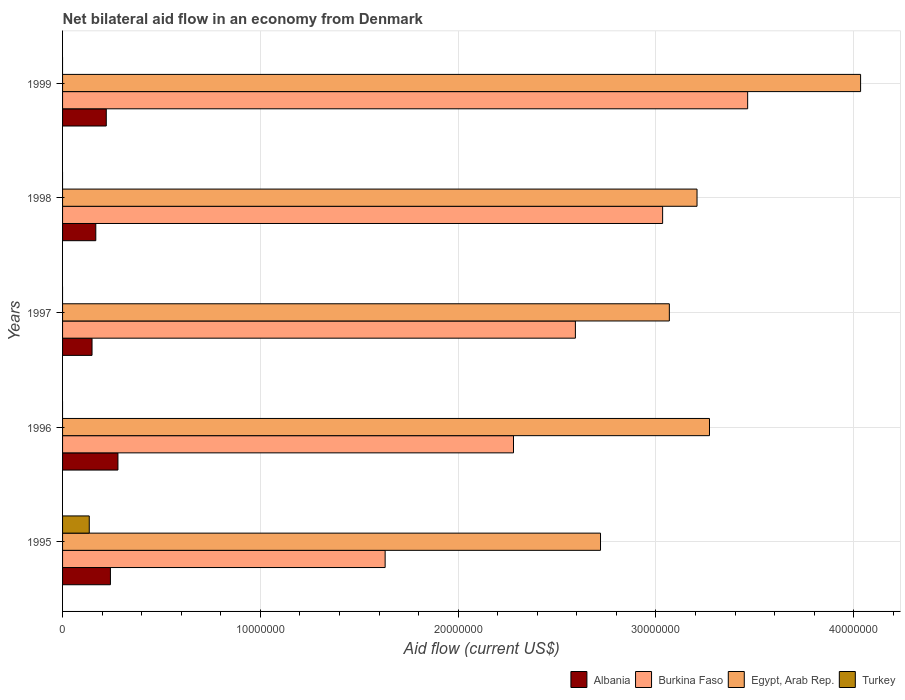How many groups of bars are there?
Provide a succinct answer. 5. How many bars are there on the 1st tick from the bottom?
Provide a succinct answer. 4. What is the label of the 2nd group of bars from the top?
Your answer should be compact. 1998. What is the net bilateral aid flow in Turkey in 1996?
Your answer should be very brief. 0. Across all years, what is the maximum net bilateral aid flow in Turkey?
Give a very brief answer. 1.35e+06. Across all years, what is the minimum net bilateral aid flow in Egypt, Arab Rep.?
Provide a short and direct response. 2.72e+07. What is the total net bilateral aid flow in Albania in the graph?
Ensure brevity in your answer.  1.06e+07. What is the difference between the net bilateral aid flow in Egypt, Arab Rep. in 1998 and that in 1999?
Your response must be concise. -8.27e+06. What is the difference between the net bilateral aid flow in Egypt, Arab Rep. in 1996 and the net bilateral aid flow in Burkina Faso in 1998?
Make the answer very short. 2.37e+06. What is the average net bilateral aid flow in Albania per year?
Keep it short and to the point. 2.12e+06. In the year 1995, what is the difference between the net bilateral aid flow in Burkina Faso and net bilateral aid flow in Albania?
Offer a very short reply. 1.39e+07. What is the ratio of the net bilateral aid flow in Egypt, Arab Rep. in 1996 to that in 1997?
Give a very brief answer. 1.07. Is the net bilateral aid flow in Albania in 1995 less than that in 1998?
Your response must be concise. No. What is the difference between the highest and the second highest net bilateral aid flow in Egypt, Arab Rep.?
Make the answer very short. 7.64e+06. What is the difference between the highest and the lowest net bilateral aid flow in Egypt, Arab Rep.?
Make the answer very short. 1.32e+07. In how many years, is the net bilateral aid flow in Burkina Faso greater than the average net bilateral aid flow in Burkina Faso taken over all years?
Ensure brevity in your answer.  2. Is the sum of the net bilateral aid flow in Albania in 1997 and 1999 greater than the maximum net bilateral aid flow in Burkina Faso across all years?
Provide a succinct answer. No. Is it the case that in every year, the sum of the net bilateral aid flow in Turkey and net bilateral aid flow in Burkina Faso is greater than the net bilateral aid flow in Egypt, Arab Rep.?
Give a very brief answer. No. How many bars are there?
Keep it short and to the point. 16. How many years are there in the graph?
Give a very brief answer. 5. Does the graph contain any zero values?
Your answer should be compact. Yes. Does the graph contain grids?
Offer a terse response. Yes. What is the title of the graph?
Keep it short and to the point. Net bilateral aid flow in an economy from Denmark. What is the label or title of the Y-axis?
Offer a very short reply. Years. What is the Aid flow (current US$) of Albania in 1995?
Provide a succinct answer. 2.42e+06. What is the Aid flow (current US$) of Burkina Faso in 1995?
Offer a terse response. 1.63e+07. What is the Aid flow (current US$) of Egypt, Arab Rep. in 1995?
Make the answer very short. 2.72e+07. What is the Aid flow (current US$) in Turkey in 1995?
Offer a very short reply. 1.35e+06. What is the Aid flow (current US$) in Albania in 1996?
Give a very brief answer. 2.80e+06. What is the Aid flow (current US$) of Burkina Faso in 1996?
Offer a very short reply. 2.28e+07. What is the Aid flow (current US$) in Egypt, Arab Rep. in 1996?
Your answer should be compact. 3.27e+07. What is the Aid flow (current US$) of Albania in 1997?
Give a very brief answer. 1.49e+06. What is the Aid flow (current US$) in Burkina Faso in 1997?
Your answer should be very brief. 2.59e+07. What is the Aid flow (current US$) in Egypt, Arab Rep. in 1997?
Provide a short and direct response. 3.07e+07. What is the Aid flow (current US$) in Albania in 1998?
Your answer should be very brief. 1.68e+06. What is the Aid flow (current US$) of Burkina Faso in 1998?
Keep it short and to the point. 3.03e+07. What is the Aid flow (current US$) of Egypt, Arab Rep. in 1998?
Offer a terse response. 3.21e+07. What is the Aid flow (current US$) in Albania in 1999?
Ensure brevity in your answer.  2.21e+06. What is the Aid flow (current US$) of Burkina Faso in 1999?
Keep it short and to the point. 3.46e+07. What is the Aid flow (current US$) in Egypt, Arab Rep. in 1999?
Your response must be concise. 4.04e+07. Across all years, what is the maximum Aid flow (current US$) of Albania?
Make the answer very short. 2.80e+06. Across all years, what is the maximum Aid flow (current US$) of Burkina Faso?
Your response must be concise. 3.46e+07. Across all years, what is the maximum Aid flow (current US$) of Egypt, Arab Rep.?
Keep it short and to the point. 4.04e+07. Across all years, what is the maximum Aid flow (current US$) in Turkey?
Give a very brief answer. 1.35e+06. Across all years, what is the minimum Aid flow (current US$) in Albania?
Provide a short and direct response. 1.49e+06. Across all years, what is the minimum Aid flow (current US$) of Burkina Faso?
Provide a succinct answer. 1.63e+07. Across all years, what is the minimum Aid flow (current US$) in Egypt, Arab Rep.?
Ensure brevity in your answer.  2.72e+07. Across all years, what is the minimum Aid flow (current US$) of Turkey?
Make the answer very short. 0. What is the total Aid flow (current US$) in Albania in the graph?
Provide a short and direct response. 1.06e+07. What is the total Aid flow (current US$) of Burkina Faso in the graph?
Keep it short and to the point. 1.30e+08. What is the total Aid flow (current US$) in Egypt, Arab Rep. in the graph?
Make the answer very short. 1.63e+08. What is the total Aid flow (current US$) in Turkey in the graph?
Provide a succinct answer. 1.35e+06. What is the difference between the Aid flow (current US$) of Albania in 1995 and that in 1996?
Keep it short and to the point. -3.80e+05. What is the difference between the Aid flow (current US$) of Burkina Faso in 1995 and that in 1996?
Your response must be concise. -6.49e+06. What is the difference between the Aid flow (current US$) in Egypt, Arab Rep. in 1995 and that in 1996?
Your response must be concise. -5.51e+06. What is the difference between the Aid flow (current US$) of Albania in 1995 and that in 1997?
Your answer should be compact. 9.30e+05. What is the difference between the Aid flow (current US$) of Burkina Faso in 1995 and that in 1997?
Your response must be concise. -9.62e+06. What is the difference between the Aid flow (current US$) in Egypt, Arab Rep. in 1995 and that in 1997?
Make the answer very short. -3.48e+06. What is the difference between the Aid flow (current US$) in Albania in 1995 and that in 1998?
Offer a terse response. 7.40e+05. What is the difference between the Aid flow (current US$) in Burkina Faso in 1995 and that in 1998?
Provide a succinct answer. -1.40e+07. What is the difference between the Aid flow (current US$) in Egypt, Arab Rep. in 1995 and that in 1998?
Provide a succinct answer. -4.88e+06. What is the difference between the Aid flow (current US$) of Burkina Faso in 1995 and that in 1999?
Give a very brief answer. -1.83e+07. What is the difference between the Aid flow (current US$) in Egypt, Arab Rep. in 1995 and that in 1999?
Keep it short and to the point. -1.32e+07. What is the difference between the Aid flow (current US$) of Albania in 1996 and that in 1997?
Provide a succinct answer. 1.31e+06. What is the difference between the Aid flow (current US$) in Burkina Faso in 1996 and that in 1997?
Your answer should be very brief. -3.13e+06. What is the difference between the Aid flow (current US$) of Egypt, Arab Rep. in 1996 and that in 1997?
Make the answer very short. 2.03e+06. What is the difference between the Aid flow (current US$) of Albania in 1996 and that in 1998?
Make the answer very short. 1.12e+06. What is the difference between the Aid flow (current US$) of Burkina Faso in 1996 and that in 1998?
Ensure brevity in your answer.  -7.54e+06. What is the difference between the Aid flow (current US$) in Egypt, Arab Rep. in 1996 and that in 1998?
Give a very brief answer. 6.30e+05. What is the difference between the Aid flow (current US$) in Albania in 1996 and that in 1999?
Make the answer very short. 5.90e+05. What is the difference between the Aid flow (current US$) of Burkina Faso in 1996 and that in 1999?
Keep it short and to the point. -1.18e+07. What is the difference between the Aid flow (current US$) of Egypt, Arab Rep. in 1996 and that in 1999?
Your answer should be very brief. -7.64e+06. What is the difference between the Aid flow (current US$) in Burkina Faso in 1997 and that in 1998?
Keep it short and to the point. -4.41e+06. What is the difference between the Aid flow (current US$) in Egypt, Arab Rep. in 1997 and that in 1998?
Provide a short and direct response. -1.40e+06. What is the difference between the Aid flow (current US$) of Albania in 1997 and that in 1999?
Make the answer very short. -7.20e+05. What is the difference between the Aid flow (current US$) of Burkina Faso in 1997 and that in 1999?
Your answer should be compact. -8.71e+06. What is the difference between the Aid flow (current US$) in Egypt, Arab Rep. in 1997 and that in 1999?
Your response must be concise. -9.67e+06. What is the difference between the Aid flow (current US$) of Albania in 1998 and that in 1999?
Give a very brief answer. -5.30e+05. What is the difference between the Aid flow (current US$) in Burkina Faso in 1998 and that in 1999?
Provide a succinct answer. -4.30e+06. What is the difference between the Aid flow (current US$) of Egypt, Arab Rep. in 1998 and that in 1999?
Make the answer very short. -8.27e+06. What is the difference between the Aid flow (current US$) of Albania in 1995 and the Aid flow (current US$) of Burkina Faso in 1996?
Your answer should be compact. -2.04e+07. What is the difference between the Aid flow (current US$) in Albania in 1995 and the Aid flow (current US$) in Egypt, Arab Rep. in 1996?
Offer a very short reply. -3.03e+07. What is the difference between the Aid flow (current US$) of Burkina Faso in 1995 and the Aid flow (current US$) of Egypt, Arab Rep. in 1996?
Make the answer very short. -1.64e+07. What is the difference between the Aid flow (current US$) of Albania in 1995 and the Aid flow (current US$) of Burkina Faso in 1997?
Give a very brief answer. -2.35e+07. What is the difference between the Aid flow (current US$) in Albania in 1995 and the Aid flow (current US$) in Egypt, Arab Rep. in 1997?
Give a very brief answer. -2.83e+07. What is the difference between the Aid flow (current US$) of Burkina Faso in 1995 and the Aid flow (current US$) of Egypt, Arab Rep. in 1997?
Provide a short and direct response. -1.44e+07. What is the difference between the Aid flow (current US$) of Albania in 1995 and the Aid flow (current US$) of Burkina Faso in 1998?
Provide a succinct answer. -2.79e+07. What is the difference between the Aid flow (current US$) in Albania in 1995 and the Aid flow (current US$) in Egypt, Arab Rep. in 1998?
Offer a terse response. -2.97e+07. What is the difference between the Aid flow (current US$) in Burkina Faso in 1995 and the Aid flow (current US$) in Egypt, Arab Rep. in 1998?
Make the answer very short. -1.58e+07. What is the difference between the Aid flow (current US$) in Albania in 1995 and the Aid flow (current US$) in Burkina Faso in 1999?
Your answer should be very brief. -3.22e+07. What is the difference between the Aid flow (current US$) of Albania in 1995 and the Aid flow (current US$) of Egypt, Arab Rep. in 1999?
Offer a terse response. -3.79e+07. What is the difference between the Aid flow (current US$) in Burkina Faso in 1995 and the Aid flow (current US$) in Egypt, Arab Rep. in 1999?
Provide a short and direct response. -2.40e+07. What is the difference between the Aid flow (current US$) in Albania in 1996 and the Aid flow (current US$) in Burkina Faso in 1997?
Your response must be concise. -2.31e+07. What is the difference between the Aid flow (current US$) in Albania in 1996 and the Aid flow (current US$) in Egypt, Arab Rep. in 1997?
Keep it short and to the point. -2.79e+07. What is the difference between the Aid flow (current US$) of Burkina Faso in 1996 and the Aid flow (current US$) of Egypt, Arab Rep. in 1997?
Give a very brief answer. -7.88e+06. What is the difference between the Aid flow (current US$) of Albania in 1996 and the Aid flow (current US$) of Burkina Faso in 1998?
Offer a very short reply. -2.75e+07. What is the difference between the Aid flow (current US$) in Albania in 1996 and the Aid flow (current US$) in Egypt, Arab Rep. in 1998?
Your response must be concise. -2.93e+07. What is the difference between the Aid flow (current US$) of Burkina Faso in 1996 and the Aid flow (current US$) of Egypt, Arab Rep. in 1998?
Make the answer very short. -9.28e+06. What is the difference between the Aid flow (current US$) in Albania in 1996 and the Aid flow (current US$) in Burkina Faso in 1999?
Ensure brevity in your answer.  -3.18e+07. What is the difference between the Aid flow (current US$) in Albania in 1996 and the Aid flow (current US$) in Egypt, Arab Rep. in 1999?
Ensure brevity in your answer.  -3.76e+07. What is the difference between the Aid flow (current US$) of Burkina Faso in 1996 and the Aid flow (current US$) of Egypt, Arab Rep. in 1999?
Keep it short and to the point. -1.76e+07. What is the difference between the Aid flow (current US$) in Albania in 1997 and the Aid flow (current US$) in Burkina Faso in 1998?
Offer a terse response. -2.88e+07. What is the difference between the Aid flow (current US$) of Albania in 1997 and the Aid flow (current US$) of Egypt, Arab Rep. in 1998?
Your answer should be compact. -3.06e+07. What is the difference between the Aid flow (current US$) of Burkina Faso in 1997 and the Aid flow (current US$) of Egypt, Arab Rep. in 1998?
Make the answer very short. -6.15e+06. What is the difference between the Aid flow (current US$) of Albania in 1997 and the Aid flow (current US$) of Burkina Faso in 1999?
Offer a terse response. -3.32e+07. What is the difference between the Aid flow (current US$) in Albania in 1997 and the Aid flow (current US$) in Egypt, Arab Rep. in 1999?
Your response must be concise. -3.89e+07. What is the difference between the Aid flow (current US$) of Burkina Faso in 1997 and the Aid flow (current US$) of Egypt, Arab Rep. in 1999?
Provide a succinct answer. -1.44e+07. What is the difference between the Aid flow (current US$) of Albania in 1998 and the Aid flow (current US$) of Burkina Faso in 1999?
Your answer should be compact. -3.30e+07. What is the difference between the Aid flow (current US$) of Albania in 1998 and the Aid flow (current US$) of Egypt, Arab Rep. in 1999?
Give a very brief answer. -3.87e+07. What is the difference between the Aid flow (current US$) in Burkina Faso in 1998 and the Aid flow (current US$) in Egypt, Arab Rep. in 1999?
Your answer should be compact. -1.00e+07. What is the average Aid flow (current US$) in Albania per year?
Your answer should be compact. 2.12e+06. What is the average Aid flow (current US$) in Burkina Faso per year?
Keep it short and to the point. 2.60e+07. What is the average Aid flow (current US$) in Egypt, Arab Rep. per year?
Your response must be concise. 3.26e+07. In the year 1995, what is the difference between the Aid flow (current US$) in Albania and Aid flow (current US$) in Burkina Faso?
Offer a terse response. -1.39e+07. In the year 1995, what is the difference between the Aid flow (current US$) in Albania and Aid flow (current US$) in Egypt, Arab Rep.?
Ensure brevity in your answer.  -2.48e+07. In the year 1995, what is the difference between the Aid flow (current US$) in Albania and Aid flow (current US$) in Turkey?
Provide a succinct answer. 1.07e+06. In the year 1995, what is the difference between the Aid flow (current US$) in Burkina Faso and Aid flow (current US$) in Egypt, Arab Rep.?
Offer a terse response. -1.09e+07. In the year 1995, what is the difference between the Aid flow (current US$) in Burkina Faso and Aid flow (current US$) in Turkey?
Ensure brevity in your answer.  1.50e+07. In the year 1995, what is the difference between the Aid flow (current US$) in Egypt, Arab Rep. and Aid flow (current US$) in Turkey?
Your answer should be very brief. 2.58e+07. In the year 1996, what is the difference between the Aid flow (current US$) in Albania and Aid flow (current US$) in Burkina Faso?
Ensure brevity in your answer.  -2.00e+07. In the year 1996, what is the difference between the Aid flow (current US$) of Albania and Aid flow (current US$) of Egypt, Arab Rep.?
Give a very brief answer. -2.99e+07. In the year 1996, what is the difference between the Aid flow (current US$) in Burkina Faso and Aid flow (current US$) in Egypt, Arab Rep.?
Your response must be concise. -9.91e+06. In the year 1997, what is the difference between the Aid flow (current US$) of Albania and Aid flow (current US$) of Burkina Faso?
Your answer should be compact. -2.44e+07. In the year 1997, what is the difference between the Aid flow (current US$) in Albania and Aid flow (current US$) in Egypt, Arab Rep.?
Offer a very short reply. -2.92e+07. In the year 1997, what is the difference between the Aid flow (current US$) in Burkina Faso and Aid flow (current US$) in Egypt, Arab Rep.?
Offer a very short reply. -4.75e+06. In the year 1998, what is the difference between the Aid flow (current US$) in Albania and Aid flow (current US$) in Burkina Faso?
Your response must be concise. -2.87e+07. In the year 1998, what is the difference between the Aid flow (current US$) of Albania and Aid flow (current US$) of Egypt, Arab Rep.?
Your answer should be compact. -3.04e+07. In the year 1998, what is the difference between the Aid flow (current US$) of Burkina Faso and Aid flow (current US$) of Egypt, Arab Rep.?
Your answer should be compact. -1.74e+06. In the year 1999, what is the difference between the Aid flow (current US$) of Albania and Aid flow (current US$) of Burkina Faso?
Your answer should be very brief. -3.24e+07. In the year 1999, what is the difference between the Aid flow (current US$) of Albania and Aid flow (current US$) of Egypt, Arab Rep.?
Ensure brevity in your answer.  -3.81e+07. In the year 1999, what is the difference between the Aid flow (current US$) in Burkina Faso and Aid flow (current US$) in Egypt, Arab Rep.?
Offer a terse response. -5.71e+06. What is the ratio of the Aid flow (current US$) of Albania in 1995 to that in 1996?
Offer a terse response. 0.86. What is the ratio of the Aid flow (current US$) of Burkina Faso in 1995 to that in 1996?
Provide a succinct answer. 0.72. What is the ratio of the Aid flow (current US$) in Egypt, Arab Rep. in 1995 to that in 1996?
Your response must be concise. 0.83. What is the ratio of the Aid flow (current US$) of Albania in 1995 to that in 1997?
Provide a succinct answer. 1.62. What is the ratio of the Aid flow (current US$) in Burkina Faso in 1995 to that in 1997?
Keep it short and to the point. 0.63. What is the ratio of the Aid flow (current US$) in Egypt, Arab Rep. in 1995 to that in 1997?
Ensure brevity in your answer.  0.89. What is the ratio of the Aid flow (current US$) of Albania in 1995 to that in 1998?
Give a very brief answer. 1.44. What is the ratio of the Aid flow (current US$) of Burkina Faso in 1995 to that in 1998?
Offer a very short reply. 0.54. What is the ratio of the Aid flow (current US$) of Egypt, Arab Rep. in 1995 to that in 1998?
Provide a short and direct response. 0.85. What is the ratio of the Aid flow (current US$) in Albania in 1995 to that in 1999?
Give a very brief answer. 1.09. What is the ratio of the Aid flow (current US$) of Burkina Faso in 1995 to that in 1999?
Ensure brevity in your answer.  0.47. What is the ratio of the Aid flow (current US$) of Egypt, Arab Rep. in 1995 to that in 1999?
Make the answer very short. 0.67. What is the ratio of the Aid flow (current US$) in Albania in 1996 to that in 1997?
Offer a very short reply. 1.88. What is the ratio of the Aid flow (current US$) in Burkina Faso in 1996 to that in 1997?
Provide a short and direct response. 0.88. What is the ratio of the Aid flow (current US$) in Egypt, Arab Rep. in 1996 to that in 1997?
Keep it short and to the point. 1.07. What is the ratio of the Aid flow (current US$) of Albania in 1996 to that in 1998?
Your answer should be very brief. 1.67. What is the ratio of the Aid flow (current US$) in Burkina Faso in 1996 to that in 1998?
Keep it short and to the point. 0.75. What is the ratio of the Aid flow (current US$) of Egypt, Arab Rep. in 1996 to that in 1998?
Your answer should be compact. 1.02. What is the ratio of the Aid flow (current US$) in Albania in 1996 to that in 1999?
Your answer should be very brief. 1.27. What is the ratio of the Aid flow (current US$) of Burkina Faso in 1996 to that in 1999?
Offer a terse response. 0.66. What is the ratio of the Aid flow (current US$) of Egypt, Arab Rep. in 1996 to that in 1999?
Offer a terse response. 0.81. What is the ratio of the Aid flow (current US$) in Albania in 1997 to that in 1998?
Your answer should be compact. 0.89. What is the ratio of the Aid flow (current US$) in Burkina Faso in 1997 to that in 1998?
Your response must be concise. 0.85. What is the ratio of the Aid flow (current US$) in Egypt, Arab Rep. in 1997 to that in 1998?
Offer a very short reply. 0.96. What is the ratio of the Aid flow (current US$) in Albania in 1997 to that in 1999?
Provide a short and direct response. 0.67. What is the ratio of the Aid flow (current US$) in Burkina Faso in 1997 to that in 1999?
Your answer should be very brief. 0.75. What is the ratio of the Aid flow (current US$) of Egypt, Arab Rep. in 1997 to that in 1999?
Make the answer very short. 0.76. What is the ratio of the Aid flow (current US$) of Albania in 1998 to that in 1999?
Provide a succinct answer. 0.76. What is the ratio of the Aid flow (current US$) of Burkina Faso in 1998 to that in 1999?
Offer a terse response. 0.88. What is the ratio of the Aid flow (current US$) of Egypt, Arab Rep. in 1998 to that in 1999?
Your response must be concise. 0.8. What is the difference between the highest and the second highest Aid flow (current US$) in Albania?
Your answer should be compact. 3.80e+05. What is the difference between the highest and the second highest Aid flow (current US$) of Burkina Faso?
Provide a succinct answer. 4.30e+06. What is the difference between the highest and the second highest Aid flow (current US$) of Egypt, Arab Rep.?
Provide a short and direct response. 7.64e+06. What is the difference between the highest and the lowest Aid flow (current US$) in Albania?
Your answer should be compact. 1.31e+06. What is the difference between the highest and the lowest Aid flow (current US$) of Burkina Faso?
Ensure brevity in your answer.  1.83e+07. What is the difference between the highest and the lowest Aid flow (current US$) of Egypt, Arab Rep.?
Provide a short and direct response. 1.32e+07. What is the difference between the highest and the lowest Aid flow (current US$) of Turkey?
Offer a terse response. 1.35e+06. 